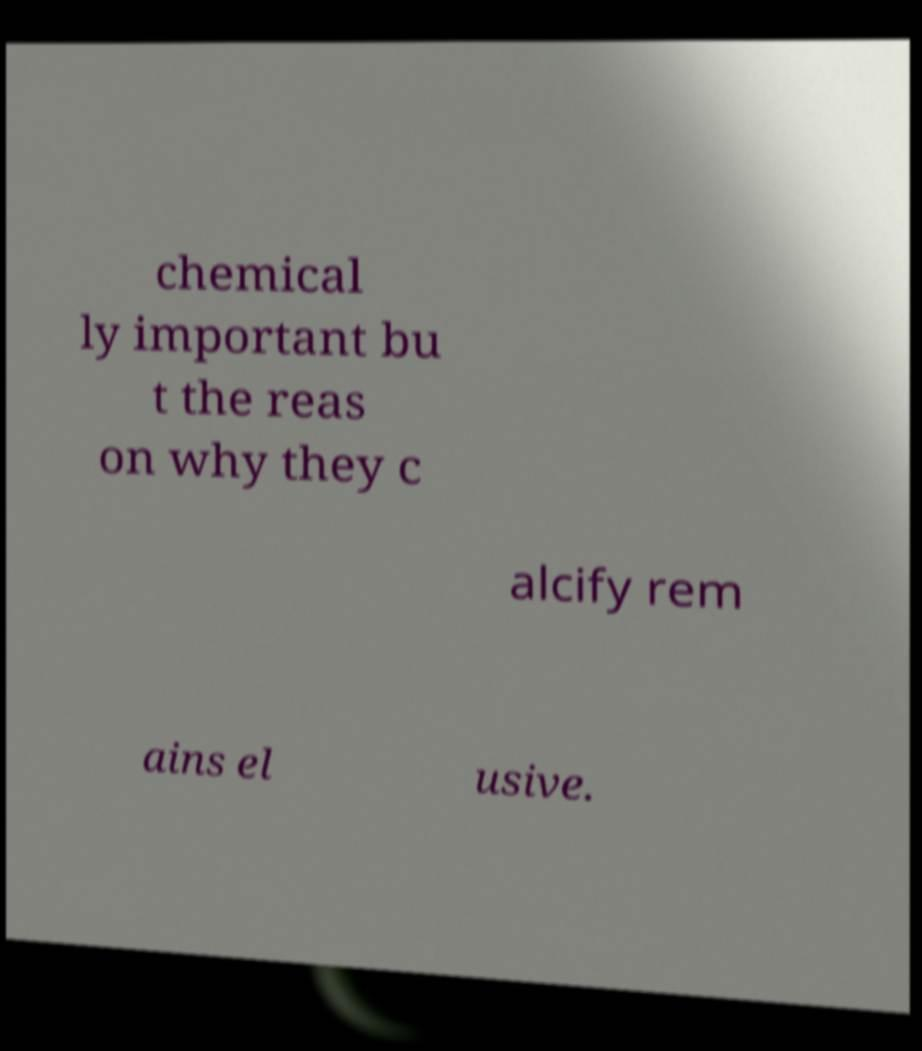I need the written content from this picture converted into text. Can you do that? chemical ly important bu t the reas on why they c alcify rem ains el usive. 